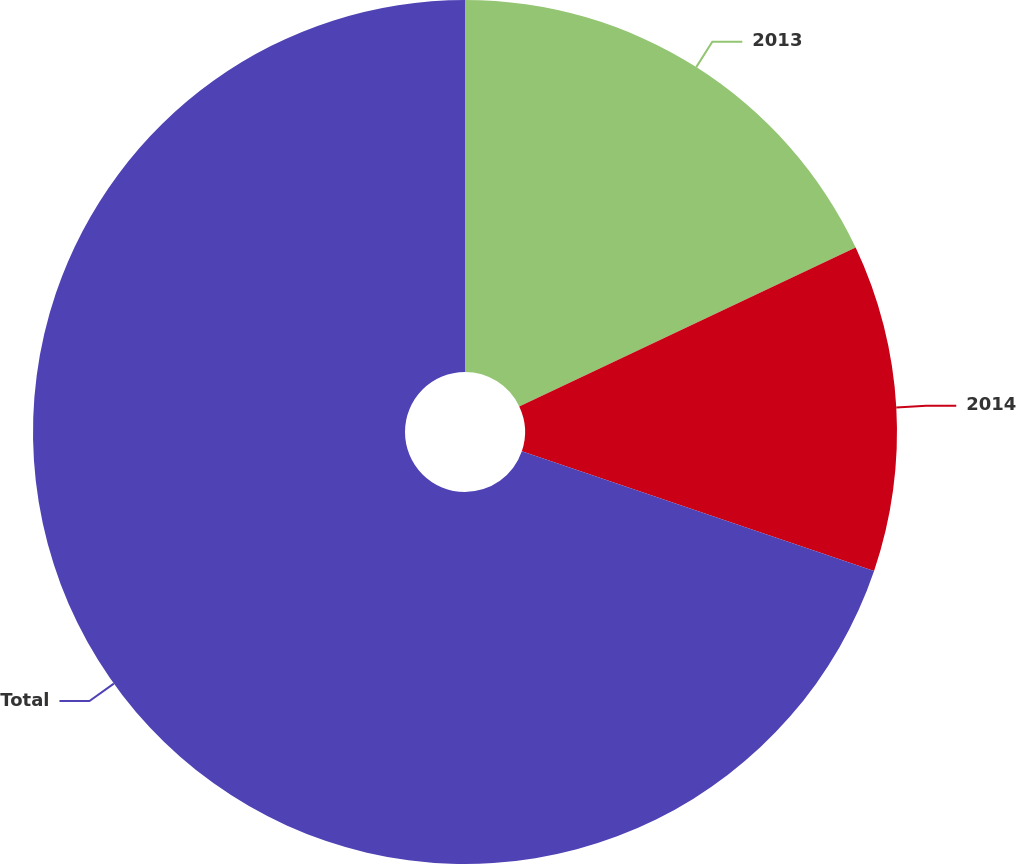Convert chart. <chart><loc_0><loc_0><loc_500><loc_500><pie_chart><fcel>2013<fcel>2014<fcel>Total<nl><fcel>17.98%<fcel>12.23%<fcel>69.79%<nl></chart> 